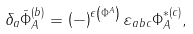Convert formula to latex. <formula><loc_0><loc_0><loc_500><loc_500>\delta _ { a } \bar { \Phi } _ { A } ^ { ( b ) } = \left ( - \right ) ^ { \epsilon \left ( \Phi ^ { A } \right ) } \varepsilon _ { a b c } \Phi _ { A } ^ { * ( c ) } ,</formula> 